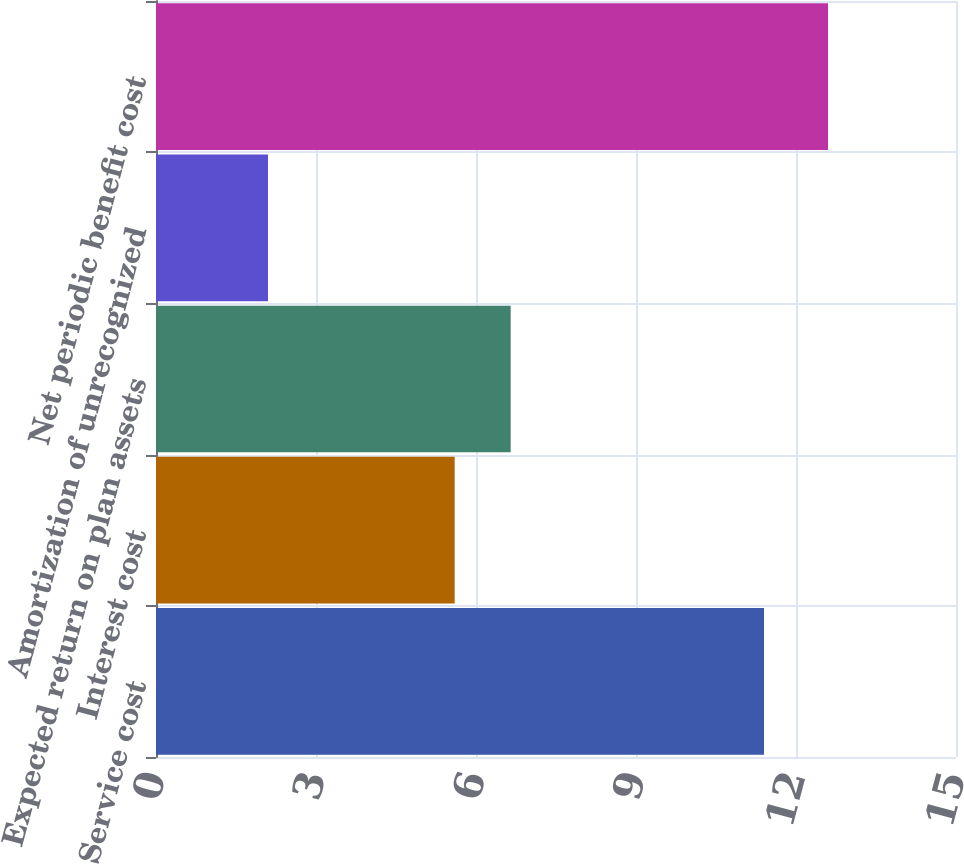Convert chart to OTSL. <chart><loc_0><loc_0><loc_500><loc_500><bar_chart><fcel>Service cost<fcel>Interest cost<fcel>Expected return on plan assets<fcel>Amortization of unrecognized<fcel>Net periodic benefit cost<nl><fcel>11.4<fcel>5.6<fcel>6.65<fcel>2.1<fcel>12.6<nl></chart> 